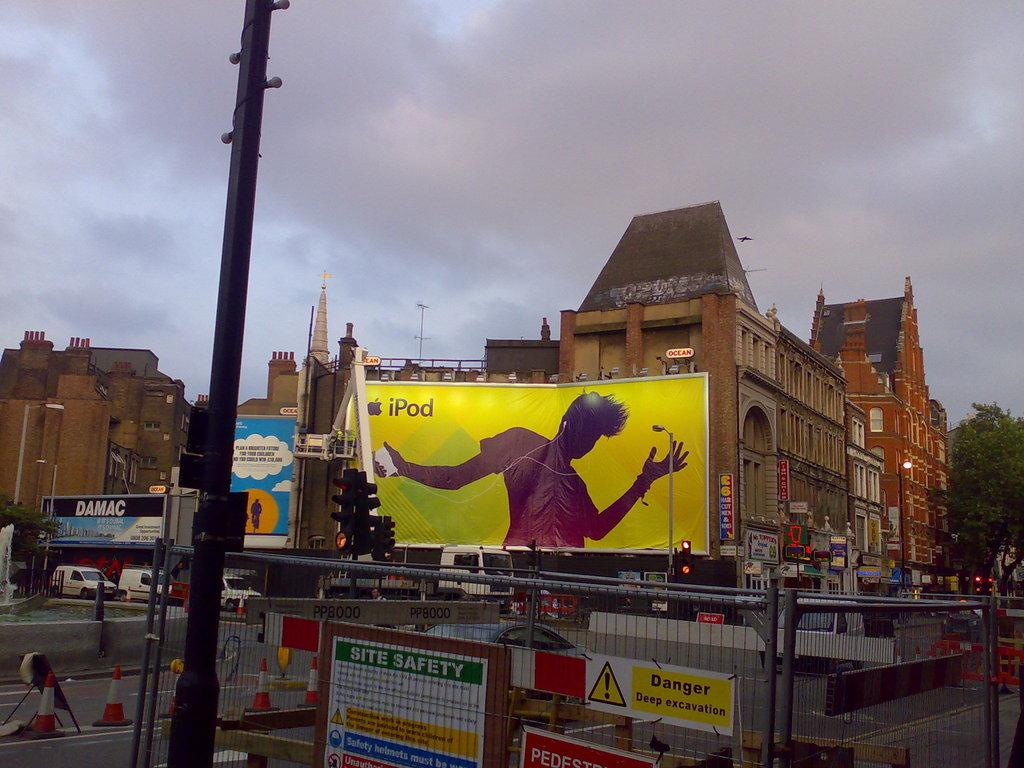<image>
Provide a brief description of the given image. city with a large yellow billboard that has an ipod ad on it 